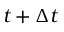<formula> <loc_0><loc_0><loc_500><loc_500>t + \Delta t</formula> 